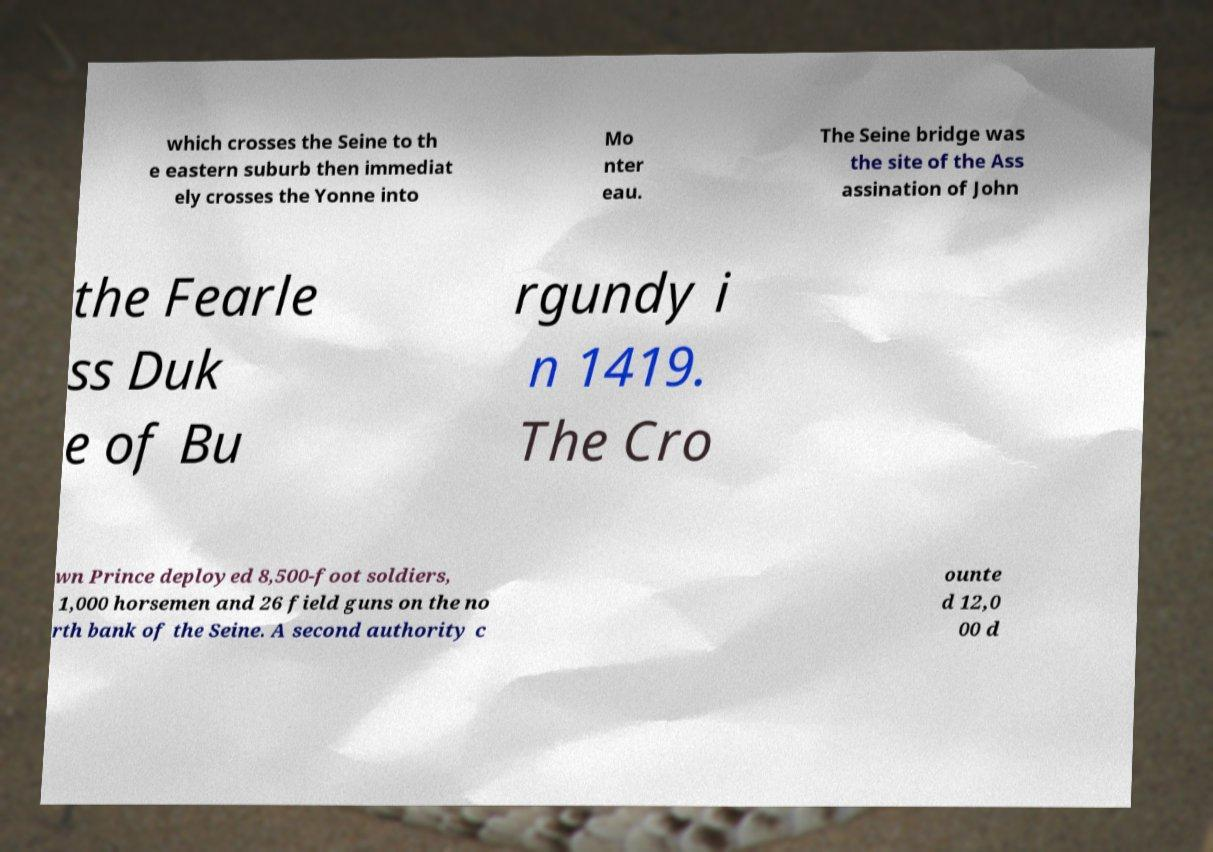For documentation purposes, I need the text within this image transcribed. Could you provide that? which crosses the Seine to th e eastern suburb then immediat ely crosses the Yonne into Mo nter eau. The Seine bridge was the site of the Ass assination of John the Fearle ss Duk e of Bu rgundy i n 1419. The Cro wn Prince deployed 8,500-foot soldiers, 1,000 horsemen and 26 field guns on the no rth bank of the Seine. A second authority c ounte d 12,0 00 d 